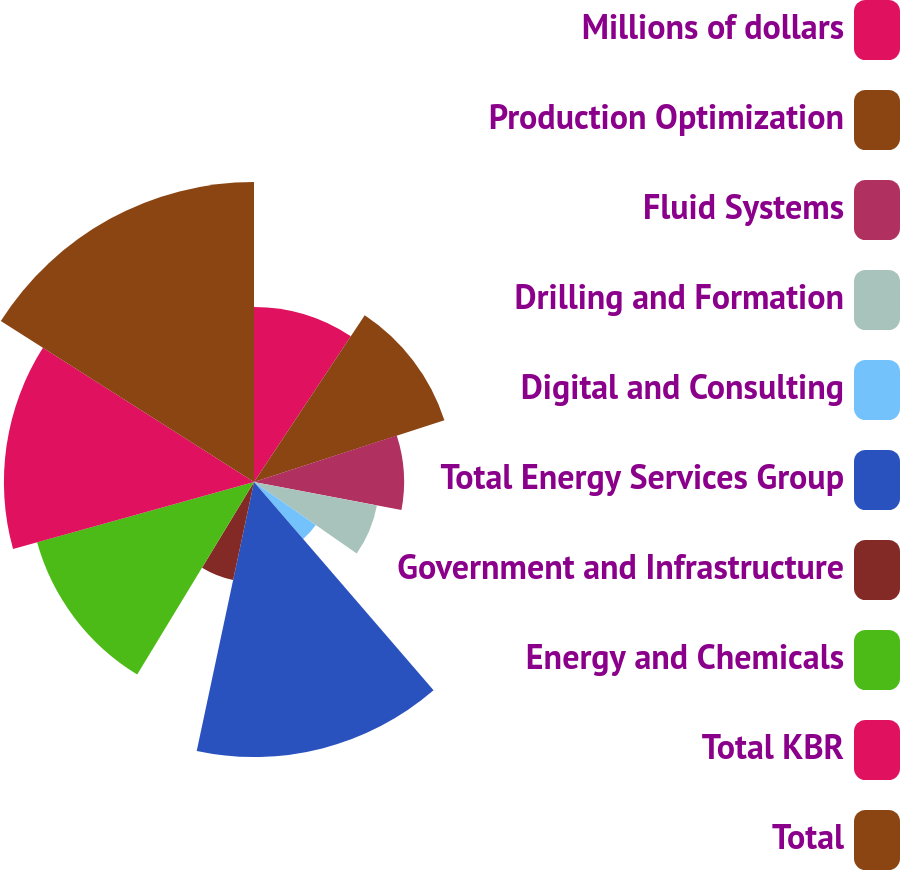Convert chart to OTSL. <chart><loc_0><loc_0><loc_500><loc_500><pie_chart><fcel>Millions of dollars<fcel>Production Optimization<fcel>Fluid Systems<fcel>Drilling and Formation<fcel>Digital and Consulting<fcel>Total Energy Services Group<fcel>Government and Infrastructure<fcel>Energy and Chemicals<fcel>Total KBR<fcel>Total<nl><fcel>9.33%<fcel>10.67%<fcel>8.0%<fcel>6.67%<fcel>4.01%<fcel>14.66%<fcel>5.34%<fcel>12.0%<fcel>13.33%<fcel>15.99%<nl></chart> 